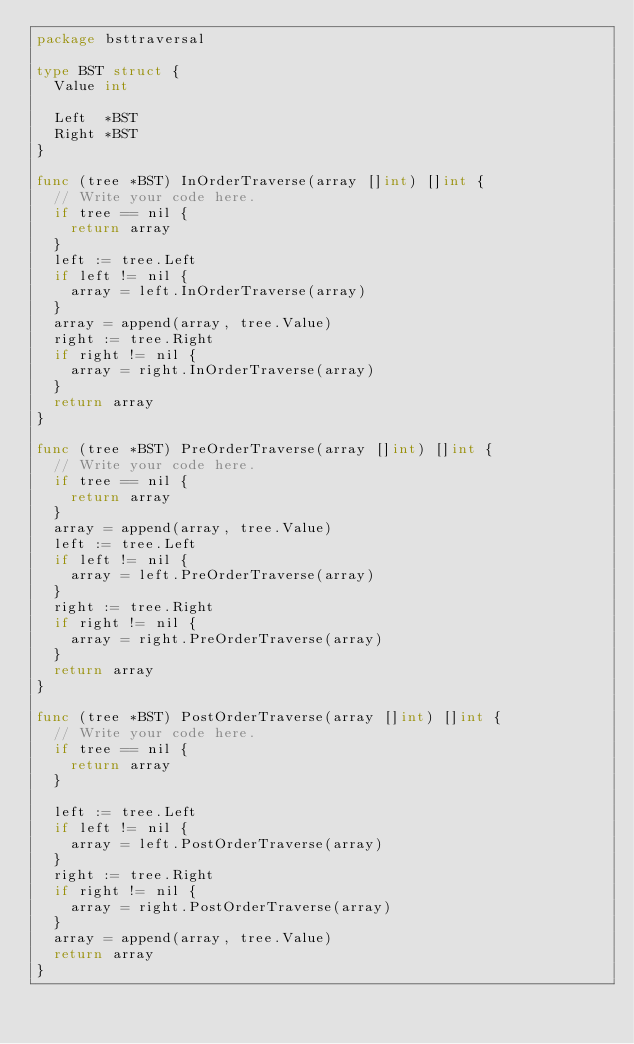Convert code to text. <code><loc_0><loc_0><loc_500><loc_500><_Go_>package bsttraversal

type BST struct {
	Value int

	Left  *BST
	Right *BST
}

func (tree *BST) InOrderTraverse(array []int) []int {
	// Write your code here.
	if tree == nil {
		return array
	}
	left := tree.Left
	if left != nil {
		array = left.InOrderTraverse(array)
	}
	array = append(array, tree.Value)
	right := tree.Right
	if right != nil {
		array = right.InOrderTraverse(array)
	}
	return array
}

func (tree *BST) PreOrderTraverse(array []int) []int {
	// Write your code here.
	if tree == nil {
		return array
	}
	array = append(array, tree.Value)
	left := tree.Left
	if left != nil {
		array = left.PreOrderTraverse(array)
	}
	right := tree.Right
	if right != nil {
		array = right.PreOrderTraverse(array)
	}
	return array
}

func (tree *BST) PostOrderTraverse(array []int) []int {
	// Write your code here.
	if tree == nil {
		return array
	}

	left := tree.Left
	if left != nil {
		array = left.PostOrderTraverse(array)
	}
	right := tree.Right
	if right != nil {
		array = right.PostOrderTraverse(array)
	}
	array = append(array, tree.Value)
	return array
}
</code> 